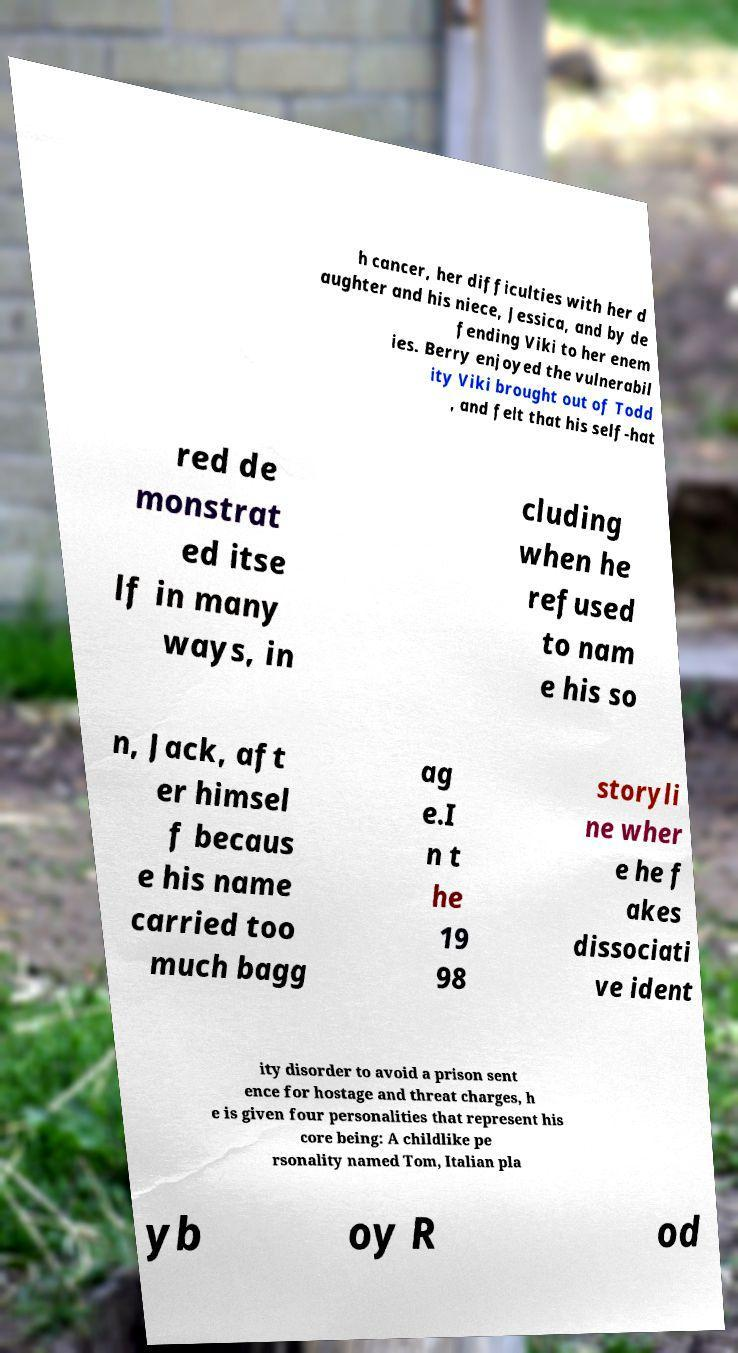Can you read and provide the text displayed in the image?This photo seems to have some interesting text. Can you extract and type it out for me? h cancer, her difficulties with her d aughter and his niece, Jessica, and by de fending Viki to her enem ies. Berry enjoyed the vulnerabil ity Viki brought out of Todd , and felt that his self-hat red de monstrat ed itse lf in many ways, in cluding when he refused to nam e his so n, Jack, aft er himsel f becaus e his name carried too much bagg ag e.I n t he 19 98 storyli ne wher e he f akes dissociati ve ident ity disorder to avoid a prison sent ence for hostage and threat charges, h e is given four personalities that represent his core being: A childlike pe rsonality named Tom, Italian pla yb oy R od 